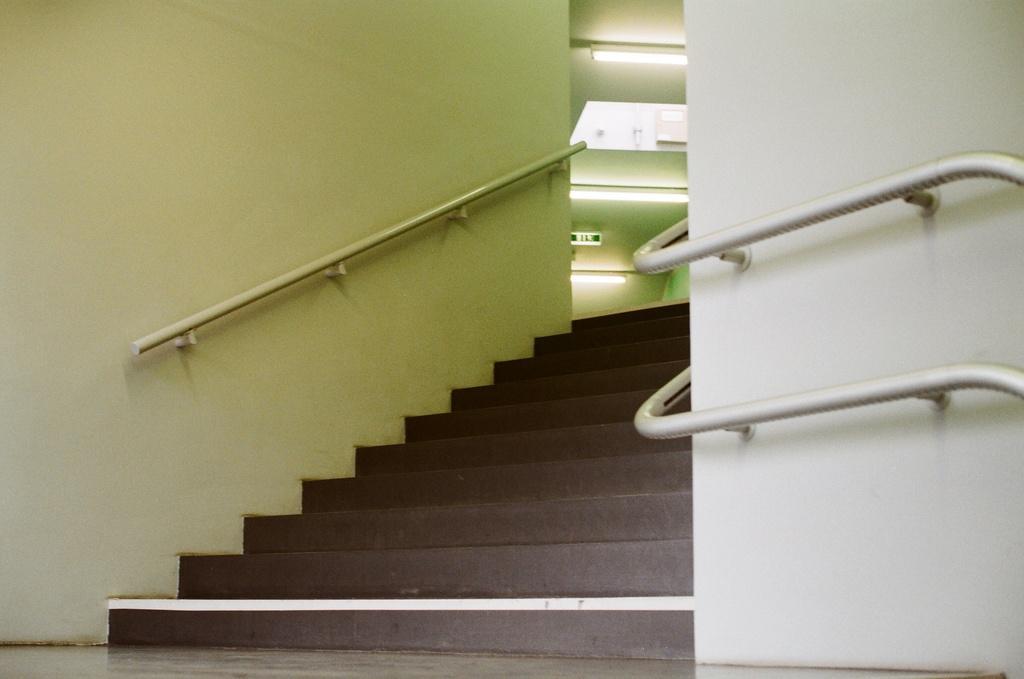How would you summarize this image in a sentence or two? In this image, we can see some stairs and railings, we can see the walls and the lights. 